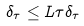Convert formula to latex. <formula><loc_0><loc_0><loc_500><loc_500>\delta _ { \tau } \leq L \tau \delta _ { \tau }</formula> 